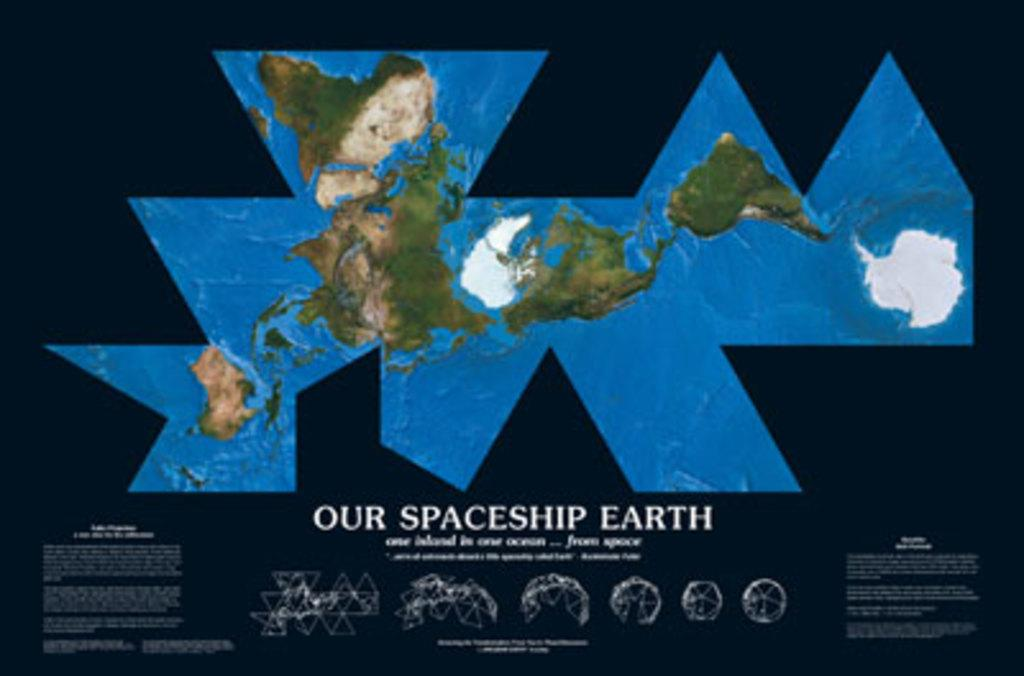<image>
Create a compact narrative representing the image presented. A map that is titled Our Spaceship Earth. 